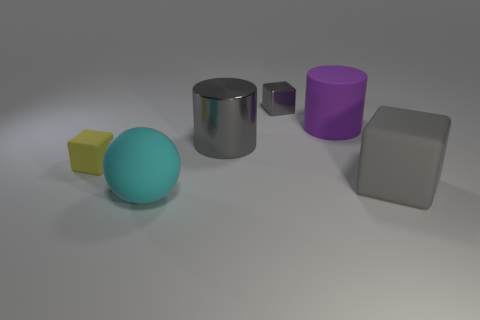What shape is the big rubber thing that is the same color as the tiny shiny block?
Your response must be concise. Cube. The matte object that is the same size as the metallic cube is what color?
Provide a succinct answer. Yellow. Are there any gray balls made of the same material as the small gray cube?
Ensure brevity in your answer.  No. Are there any gray metallic blocks on the right side of the big matte object behind the large gray thing that is in front of the small matte block?
Offer a very short reply. No. Are there any cyan rubber balls to the right of the metal block?
Offer a terse response. No. Are there any small shiny objects of the same color as the small matte thing?
Ensure brevity in your answer.  No. How many tiny objects are gray shiny blocks or yellow cubes?
Keep it short and to the point. 2. Does the tiny thing that is behind the purple thing have the same material as the cyan thing?
Keep it short and to the point. No. What shape is the large gray object that is to the left of the block on the right side of the big cylinder that is right of the big gray cylinder?
Offer a terse response. Cylinder. How many brown things are rubber balls or matte objects?
Give a very brief answer. 0. 